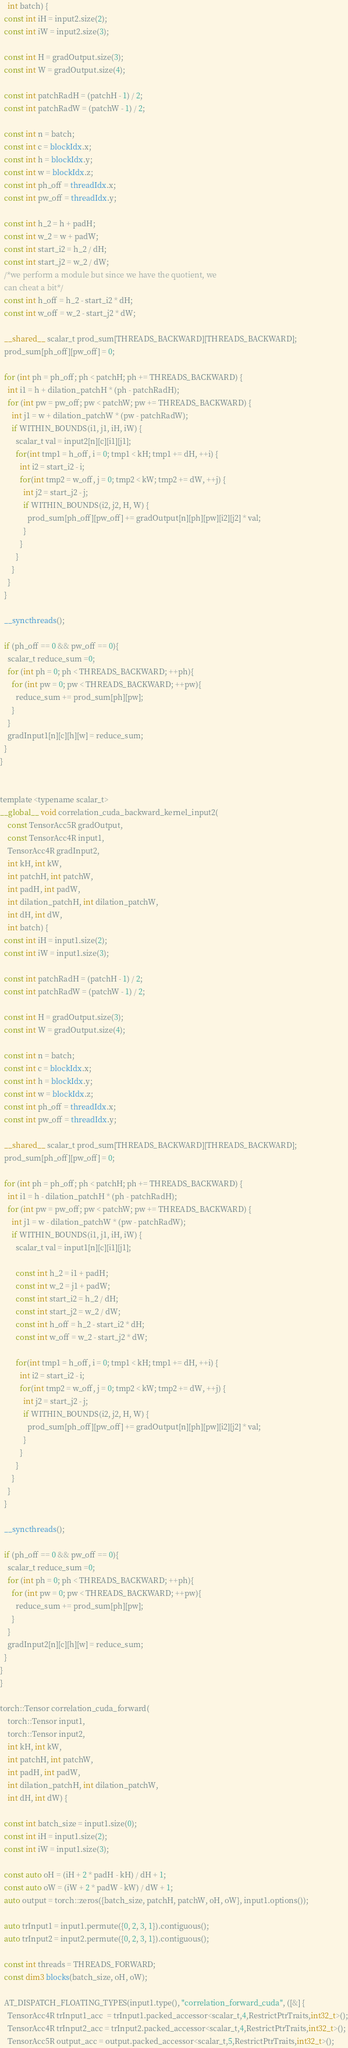<code> <loc_0><loc_0><loc_500><loc_500><_Cuda_>    int batch) {
  const int iH = input2.size(2);
  const int iW = input2.size(3);

  const int H = gradOutput.size(3);
  const int W = gradOutput.size(4);

  const int patchRadH = (patchH - 1) / 2;
  const int patchRadW = (patchW - 1) / 2;
  
  const int n = batch;
  const int c = blockIdx.x;
  const int h = blockIdx.y;
  const int w = blockIdx.z;
  const int ph_off = threadIdx.x;
  const int pw_off = threadIdx.y;

  const int h_2 = h + padH;
  const int w_2 = w + padW;
  const int start_i2 = h_2 / dH;
  const int start_j2 = w_2 / dW;
  /*we perform a module but since we have the quotient, we
  can cheat a bit*/
  const int h_off = h_2 - start_i2 * dH;
  const int w_off = w_2 - start_j2 * dW;

  __shared__ scalar_t prod_sum[THREADS_BACKWARD][THREADS_BACKWARD];
  prod_sum[ph_off][pw_off] = 0;

  for (int ph = ph_off; ph < patchH; ph += THREADS_BACKWARD) {
    int i1 = h + dilation_patchH * (ph - patchRadH);
    for (int pw = pw_off; pw < patchW; pw += THREADS_BACKWARD) {
      int j1 = w + dilation_patchW * (pw - patchRadW);
      if WITHIN_BOUNDS(i1, j1, iH, iW) {
        scalar_t val = input2[n][c][i1][j1];
        for(int tmp1 = h_off, i = 0; tmp1 < kH; tmp1 += dH, ++i) {
          int i2 = start_i2 - i;
          for(int tmp2 = w_off, j = 0; tmp2 < kW; tmp2 += dW, ++j) {
            int j2 = start_j2 - j;
            if WITHIN_BOUNDS(i2, j2, H, W) {
              prod_sum[ph_off][pw_off] += gradOutput[n][ph][pw][i2][j2] * val;
            }
          }
        }
      }
    }
  }

  __syncthreads();

  if (ph_off == 0 && pw_off == 0){
    scalar_t reduce_sum =0;
    for (int ph = 0; ph < THREADS_BACKWARD; ++ph){
      for (int pw = 0; pw < THREADS_BACKWARD; ++pw){
        reduce_sum += prod_sum[ph][pw];
      }
    }
    gradInput1[n][c][h][w] = reduce_sum;
  }
}


template <typename scalar_t>
__global__ void correlation_cuda_backward_kernel_input2(
    const TensorAcc5R gradOutput,
    const TensorAcc4R input1,
    TensorAcc4R gradInput2,
    int kH, int kW,
    int patchH, int patchW,
    int padH, int padW,
    int dilation_patchH, int dilation_patchW,
    int dH, int dW,
    int batch) {
  const int iH = input1.size(2);
  const int iW = input1.size(3);

  const int patchRadH = (patchH - 1) / 2;
  const int patchRadW = (patchW - 1) / 2;

  const int H = gradOutput.size(3);
  const int W = gradOutput.size(4);
  
  const int n = batch;
  const int c = blockIdx.x;
  const int h = blockIdx.y;
  const int w = blockIdx.z;
  const int ph_off = threadIdx.x;
  const int pw_off = threadIdx.y;

  __shared__ scalar_t prod_sum[THREADS_BACKWARD][THREADS_BACKWARD];
  prod_sum[ph_off][pw_off] = 0;

  for (int ph = ph_off; ph < patchH; ph += THREADS_BACKWARD) {
    int i1 = h - dilation_patchH * (ph - patchRadH);
    for (int pw = pw_off; pw < patchW; pw += THREADS_BACKWARD) {
      int j1 = w - dilation_patchW * (pw - patchRadW);
      if WITHIN_BOUNDS(i1, j1, iH, iW) {
        scalar_t val = input1[n][c][i1][j1];
        
        const int h_2 = i1 + padH;
        const int w_2 = j1 + padW;
        const int start_i2 = h_2 / dH;
        const int start_j2 = w_2 / dW;
        const int h_off = h_2 - start_i2 * dH;
        const int w_off = w_2 - start_j2 * dW;
        
        for(int tmp1 = h_off, i = 0; tmp1 < kH; tmp1 += dH, ++i) {
          int i2 = start_i2 - i;
          for(int tmp2 = w_off, j = 0; tmp2 < kW; tmp2 += dW, ++j) {
            int j2 = start_j2 - j;
            if WITHIN_BOUNDS(i2, j2, H, W) {
              prod_sum[ph_off][pw_off] += gradOutput[n][ph][pw][i2][j2] * val;
            }
          }
        }
      }
    }
  }

  __syncthreads();

  if (ph_off == 0 && pw_off == 0){
    scalar_t reduce_sum =0;
    for (int ph = 0; ph < THREADS_BACKWARD; ++ph){
      for (int pw = 0; pw < THREADS_BACKWARD; ++pw){
        reduce_sum += prod_sum[ph][pw];
      }
    }
    gradInput2[n][c][h][w] = reduce_sum;
  }
}
}

torch::Tensor correlation_cuda_forward(
    torch::Tensor input1,
    torch::Tensor input2,
    int kH, int kW,
    int patchH, int patchW,
    int padH, int padW,
    int dilation_patchH, int dilation_patchW,
    int dH, int dW) {
  
  const int batch_size = input1.size(0);
  const int iH = input1.size(2);
  const int iW = input1.size(3);

  const auto oH = (iH + 2 * padH - kH) / dH + 1;
  const auto oW = (iW + 2 * padW - kW) / dW + 1;
  auto output = torch::zeros({batch_size, patchH, patchW, oH, oW}, input1.options());
  
  auto trInput1 = input1.permute({0, 2, 3, 1}).contiguous();
  auto trInput2 = input2.permute({0, 2, 3, 1}).contiguous();
  
  const int threads = THREADS_FORWARD;
  const dim3 blocks(batch_size, oH, oW);

  AT_DISPATCH_FLOATING_TYPES(input1.type(), "correlation_forward_cuda", ([&] {
    TensorAcc4R trInput1_acc  = trInput1.packed_accessor<scalar_t,4,RestrictPtrTraits,int32_t>();
    TensorAcc4R trInput2_acc = trInput2.packed_accessor<scalar_t,4,RestrictPtrTraits,int32_t>();
    TensorAcc5R output_acc = output.packed_accessor<scalar_t,5,RestrictPtrTraits,int32_t>();</code> 